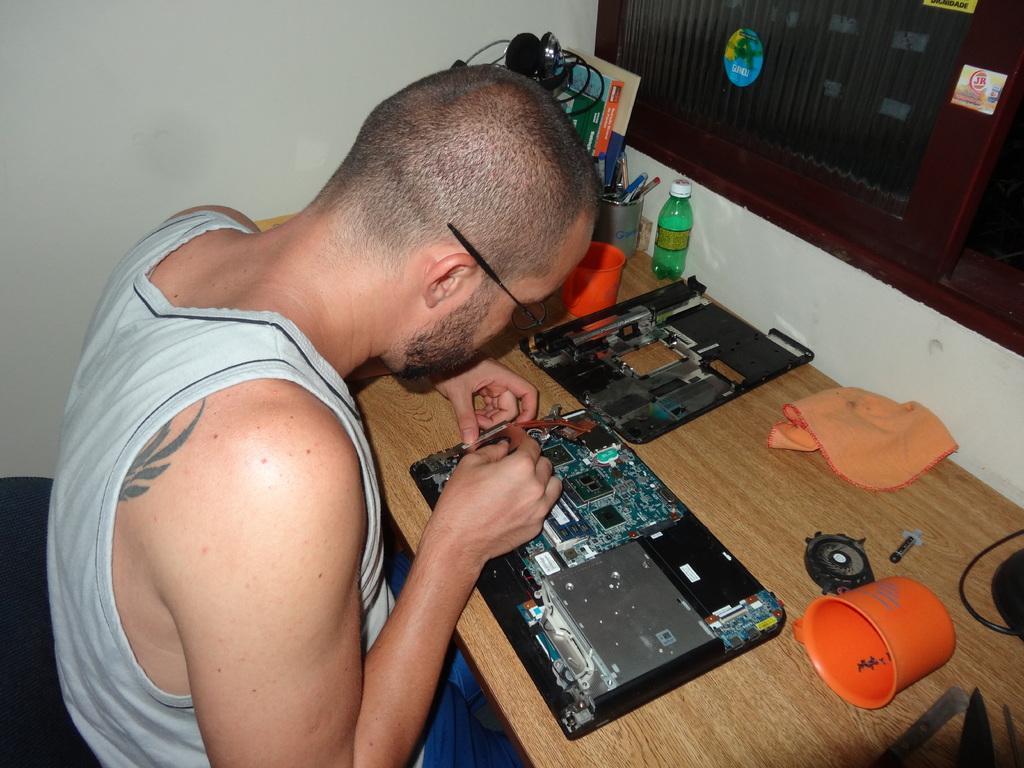In one or two sentences, can you explain what this image depicts? In this picture there is a man who is sitting on the left side of the image and there is a table in front of him, on which there is a broken laptop, it seems to be he is repairing it and there is stationery in the center of the image, on the table, there is a window in the top right side of the image. 